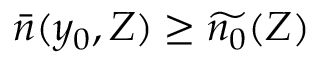Convert formula to latex. <formula><loc_0><loc_0><loc_500><loc_500>\bar { n } ( y _ { 0 } , Z ) \geq \widetilde { n _ { 0 } } ( Z )</formula> 